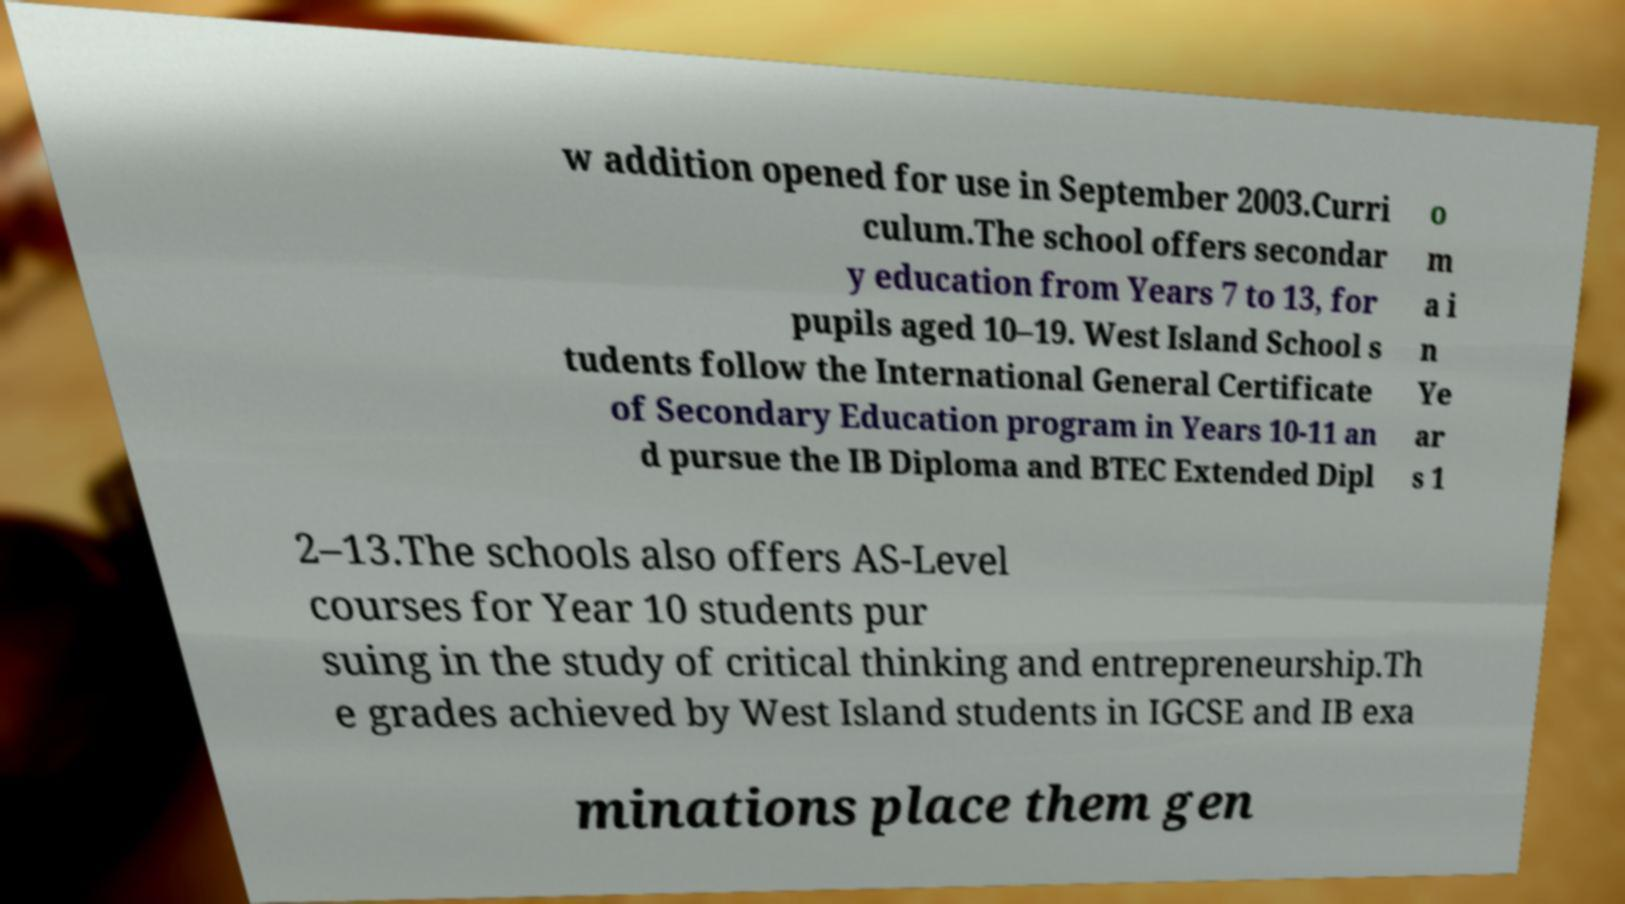For documentation purposes, I need the text within this image transcribed. Could you provide that? w addition opened for use in September 2003.Curri culum.The school offers secondar y education from Years 7 to 13, for pupils aged 10–19. West Island School s tudents follow the International General Certificate of Secondary Education program in Years 10-11 an d pursue the IB Diploma and BTEC Extended Dipl o m a i n Ye ar s 1 2–13.The schools also offers AS-Level courses for Year 10 students pur suing in the study of critical thinking and entrepreneurship.Th e grades achieved by West Island students in IGCSE and IB exa minations place them gen 